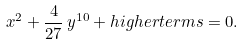<formula> <loc_0><loc_0><loc_500><loc_500>x ^ { 2 } + \frac { 4 } { 2 7 } \, y ^ { 1 0 } + h i g h e r t e r m s = 0 .</formula> 